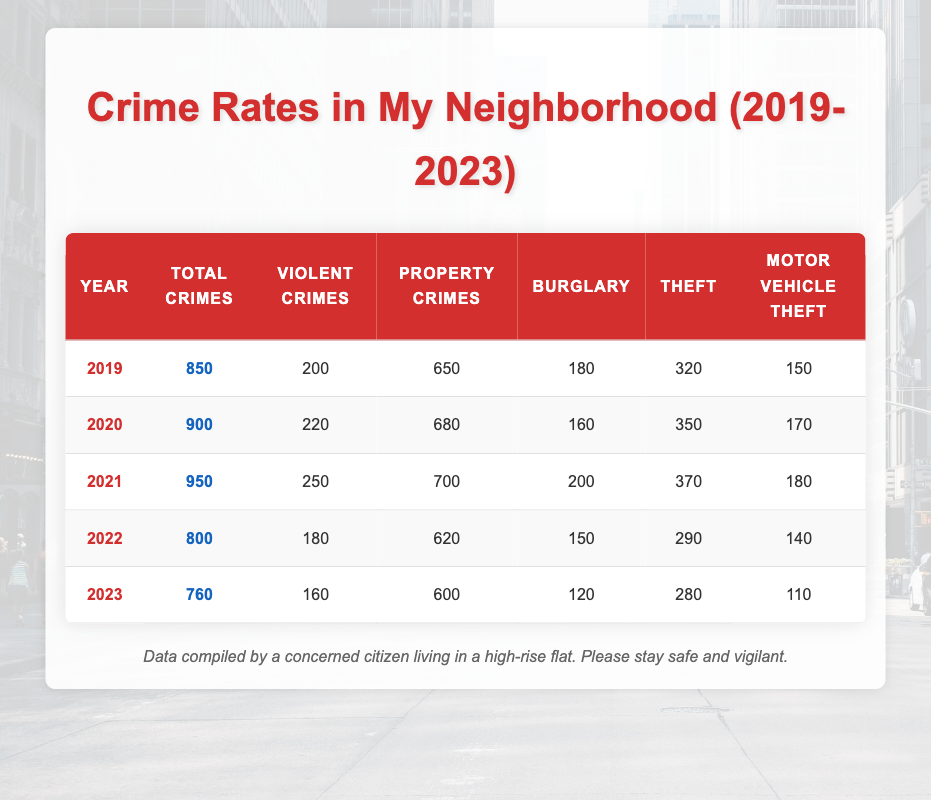What was the total number of crimes in 2021? The table shows that the "Total Crimes" for the year 2021 is listed as 950. I can find this value in the row corresponding to 2021 in the table.
Answer: 950 How many violent crimes were reported in 2020? Looking at the column for "Violent Crimes" in the table, the value for the year 2020 is noted as 220. This is a straightforward retrieval from the table.
Answer: 220 In which year did property crimes peak, and what was the number? To find the peak in "Property Crimes," I review each year's data: 650 (2019), 680 (2020), 700 (2021), 620 (2022), and 600 (2023). The highest value is 700 in the year 2021, making it the peak year for property crimes.
Answer: 2021, 700 What is the average number of motor vehicle thefts from 2019 to 2023? To calculate the average, I will sum the values for "Motor Vehicle Theft" across the years: 150 (2019) + 170 (2020) + 180 (2021) + 140 (2022) + 110 (2023) = 820. Then, I divide by the number of years, which is 5, so 820/5 = 164.
Answer: 164 Did the total number of crimes decrease from 2021 to 2023? I need to check the "Total Crimes" values for both years: 950 (2021) and 760 (2023). Since 760 is less than 950, it indicates a decrease in total crimes over these years. Thus, my answer is true.
Answer: Yes Which year had the highest number of burglaries, and how many were there? I review the "Burglary" values for each year: 180 (2019), 160 (2020), 200 (2021), 150 (2022), and 120 (2023). The highest number is 200 in 2021.
Answer: 2021, 200 Is it true that the number of violent crimes in 2022 was less than in 2021? The violent crimes for 2021 is 250, and for 2022 it is 180. Comparing these two values shows that 180 is indeed less than 250, confirming that the statement is true.
Answer: Yes What is the total number of thefts from 2019 to 2023? For total thefts, I will sum the yearly figures from the table: 320 (2019) + 350 (2020) + 370 (2021) + 290 (2022) + 280 (2023) = 1610. This gives the total number of thefts over the five-year span.
Answer: 1610 